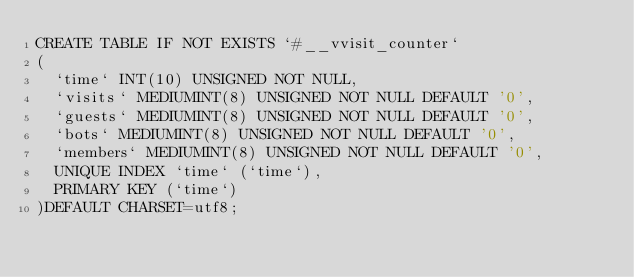Convert code to text. <code><loc_0><loc_0><loc_500><loc_500><_SQL_>CREATE TABLE IF NOT EXISTS `#__vvisit_counter` 
(
	`time` INT(10) UNSIGNED NOT NULL,
	`visits` MEDIUMINT(8) UNSIGNED NOT NULL DEFAULT '0',
	`guests` MEDIUMINT(8) UNSIGNED NOT NULL DEFAULT '0',
	`bots` MEDIUMINT(8) UNSIGNED NOT NULL DEFAULT '0',
	`members` MEDIUMINT(8) UNSIGNED NOT NULL DEFAULT '0',
	UNIQUE INDEX `time` (`time`),
	PRIMARY KEY (`time`)
)DEFAULT CHARSET=utf8;
</code> 